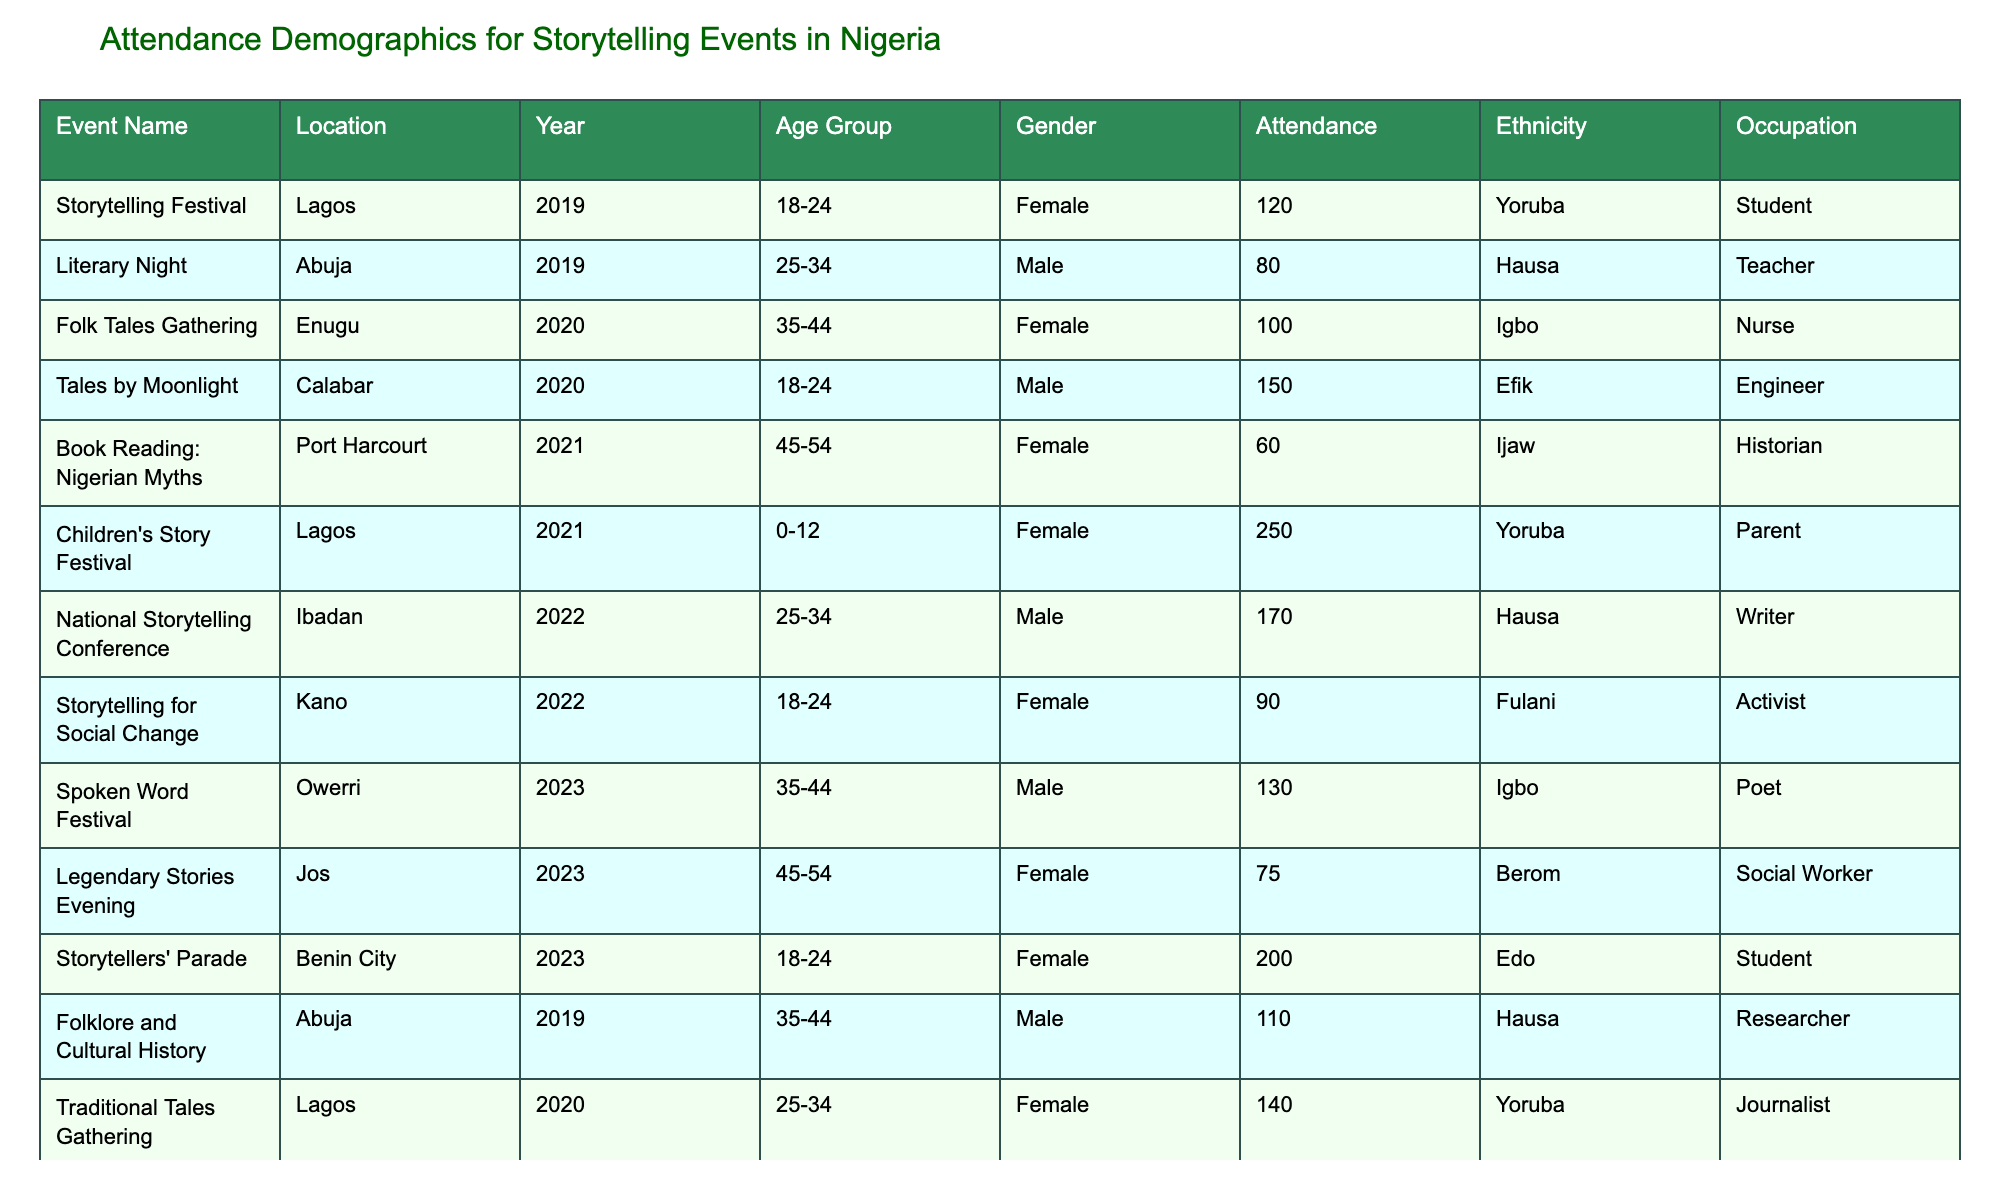What is the total attendance for storytelling events in 2021? The table shows attendance figures for 2021: Children's Story Festival (250), Intercultural Story Exchange (60), and Book Reading: Nigerian Myths (60). Summing these values: 250 + 60 + 60 = 370.
Answer: 370 Which age group had the highest attendance at the "Storytelling for Social Change" event? The event "Storytelling for Social Change" in 2022 had an attendance of 90 within the age group of 18-24. This is the only entry for this event, so no comparison is needed.
Answer: 18-24 How many events were held in Lagos? The table lists three events in Lagos: "Storytelling Festival" (2019), "Children's Story Festival" (2021), and "Traditional Tales Gathering" (2020). Counting these, there are three events.
Answer: 3 What was the average attendance for male attendees across all events? Male attendance can be summed from "Literary Night" (80), "Tales by Moonlight" (150), "National Storytelling Conference" (170), "Folklore and Cultural History" (110), "Intercultural Story Exchange" (60), and "Spoken Word Festival" (130). The total is 80 + 150 + 170 + 110 + 60 + 130 = 700. There are 6 events, so the average is 700 / 6 ≈ 116.67.
Answer: 116.67 Is there any event recorded for the ethnic group Ijaw? The table shows an event attended by an Ijaw participant, specifically the "Book Reading: Nigerian Myths" in 2021. Hence, there is at least one event for the Ijaw ethnic group.
Answer: Yes Which event had the most attendees overall? Looking at the attendance figures, the "Children's Story Festival" in 2021 had the highest attendance with 250. A comparison with other events confirms no higher figure exists.
Answer: Children's Story Festival What is the difference in attendance between the highest and lowest attended events in 2023? In 2023, the "Storytellers' Parade" had 200 attendees while "Legendary Stories Evening" had 75. The difference is 200 - 75 = 125.
Answer: 125 Which location had the highest attendance across all events? The total attendance for each location is calculated: Lagos (370), Abuja (220), Enugu (100), Calabar (150), Port Harcourt (60), and Kano (90). Therefore, Lagos has the highest total attendance.
Answer: Lagos What percentage of attendees across all events were female? The total female attendance is from "Storytelling Festival" (120), "Folk Tales Gathering" (100), "Book Reading: Nigerian Myths" (60), "Children's Story Festival" (250), "Storytelling for Social Change" (90), "Legendary Stories Evening" (75), and "Storytellers' Parade" (200), totaling 895. The overall attendance is 1,290 (sum of all attendance). Therefore, the percentage is (895/1290) * 100 ≈ 69.44%.
Answer: 69.44% How many different age groups attended events in 2022? The table shows two events in 2022 with corresponding age groups: "National Storytelling Conference" (25-34) and "Storytelling for Social Change" (18-24). Therefore, there are two different age groups present during that year.
Answer: 2 What was the most common occupation of attendees in the dataset? Analyzing the occupation column, we find the following: Student (3), Teacher (1), Nurse (1), Engineer (1), Historian (1), Parent (1), Writer (1), Activist (1), Poet (1), Social Worker (1), Researcher (1), and Journalist (1). The highest count is for "Student" with 3 occurrences, making it the most common occupation.
Answer: Student 